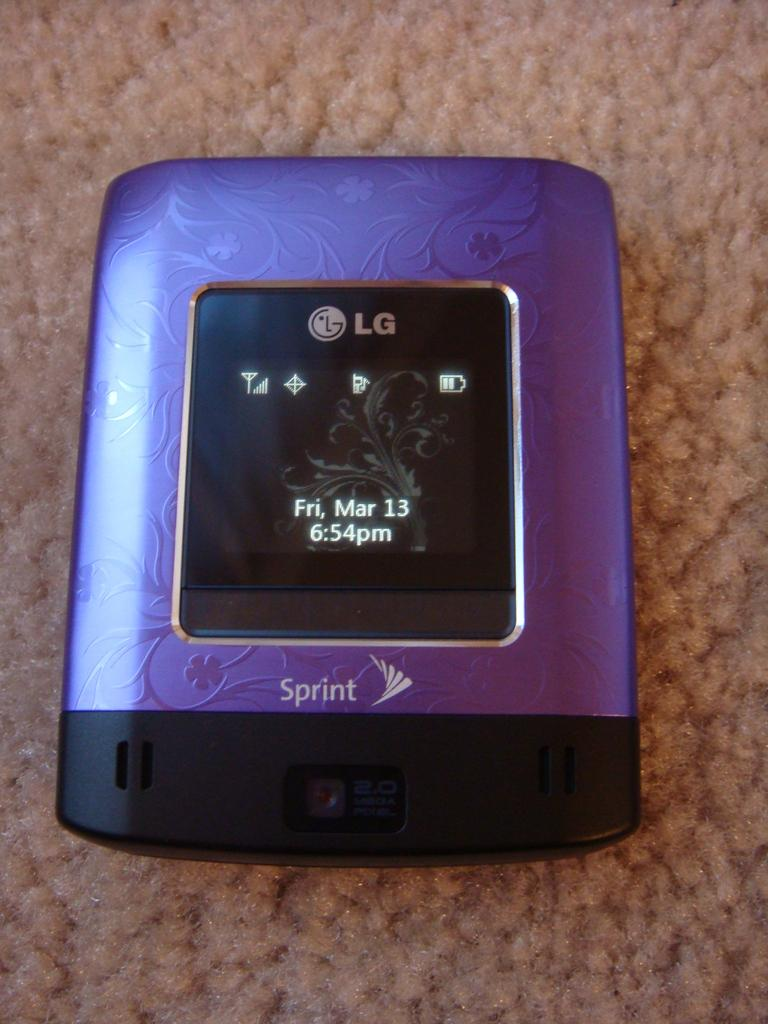<image>
Describe the image concisely. A purple LG device shows the date as Fri, Mar 13 on its display. 